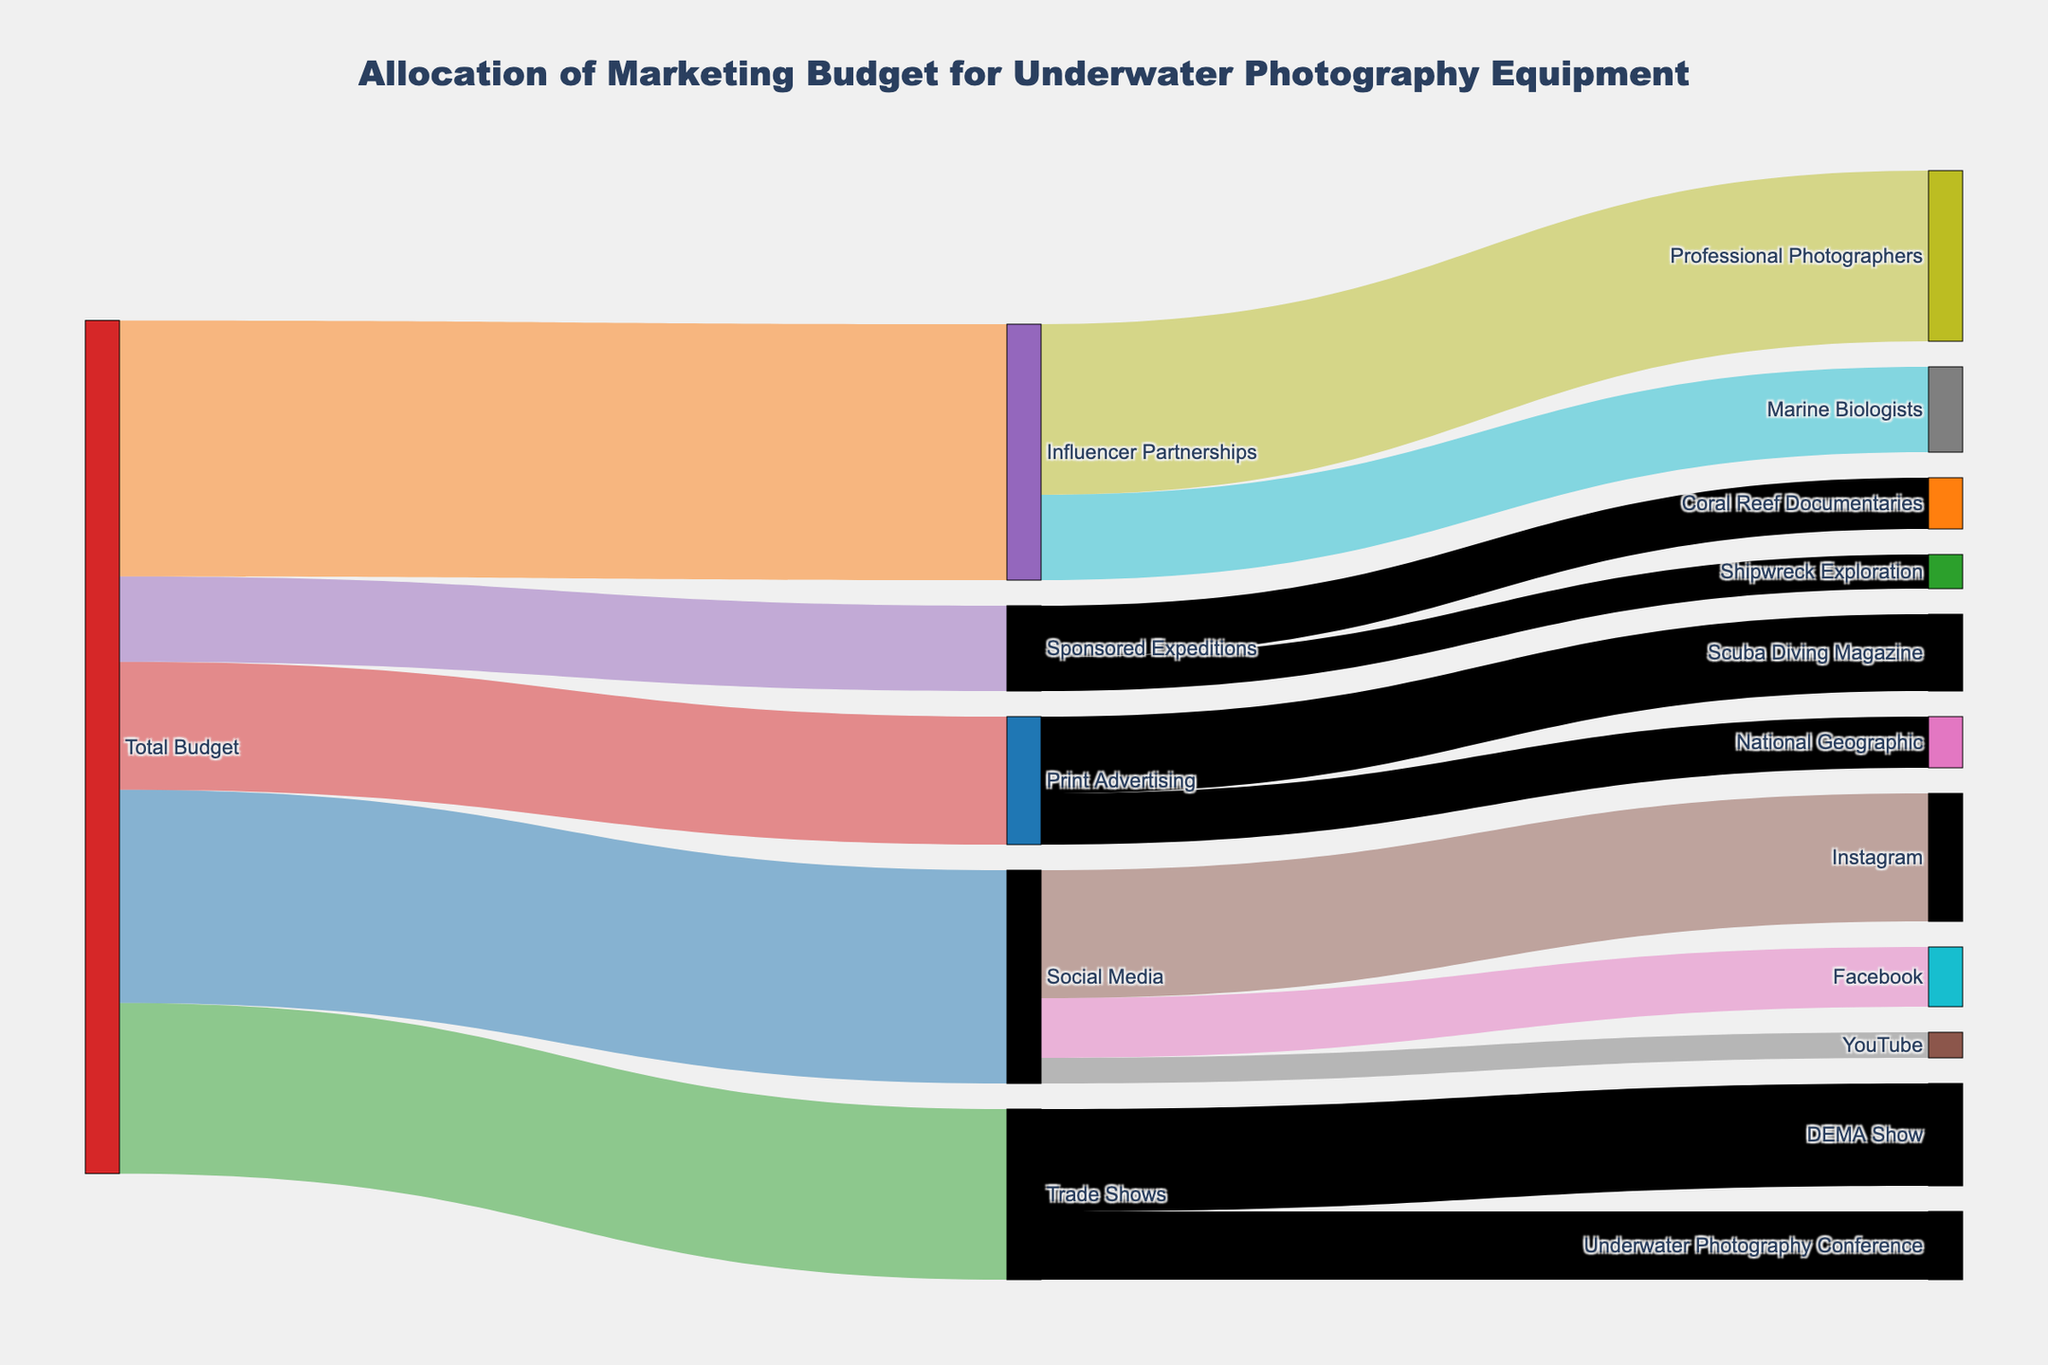What's the title of the Sankey Diagram? The title of the diagram is presented at the top and typically provides a clear summary of what the diagram represents.
Answer: Allocation of Marketing Budget for Underwater Photography Equipment How much budget is allocated to Social Media from the Total Budget? The link from "Total Budget" to "Social Media" shows the value directly.
Answer: 250000 Which promotional channel receives the highest amount of budget? By comparing the values flowing out from "Total Budget" to different channels, you can identify the largest value.
Answer: Influencer Partnerships What is the total budget allocated to Trade Shows and Influencer Partnerships combined? Sum the values allocated to Trade Shows and Influencer Partnerships from the Total Budget (200000 + 300000).
Answer: 500000 Which platform within Social Media receives the least funding? Compare the values flowing from "Social Media" to Instagram, Facebook, and YouTube. The smallest value is assigned to the platform with the least funding.
Answer: YouTube How does the budget allocation for Print Advertising to National Geographic compare to that of Scuba Diving Magazine? Subtract the value allocated to National Geographic from the value allocated to Scuba Diving Magazine (90000 - 60000).
Answer: 30000 more What is the total amount divided among Social Media platforms? Sum the values allocated to Instagram, Facebook, and YouTube (150000 + 70000 + 30000).
Answer: 250000 Is more budget allocated to Coral Reef Documentaries or Shipwreck Exploration? Compare the values assigned to Coral Reef Documentaries and Shipwreck Exploration.
Answer: Coral Reef Documentaries Which has more budget: Trade Shows or Print Advertising? Compare the values flowing from "Total Budget" to "Trade Shows" and "Print Advertising".
Answer: Trade Shows What's the proportion of budget allocated to Influencer Partnerships among Professional Photographers? The total budget for Influencer Partnerships is 300000. The budget for Professional Photographers within Influencer Partnerships is 200000. Divide the latter by the former (200000 / 300000).
Answer: 0.67 